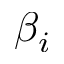<formula> <loc_0><loc_0><loc_500><loc_500>\beta _ { i }</formula> 